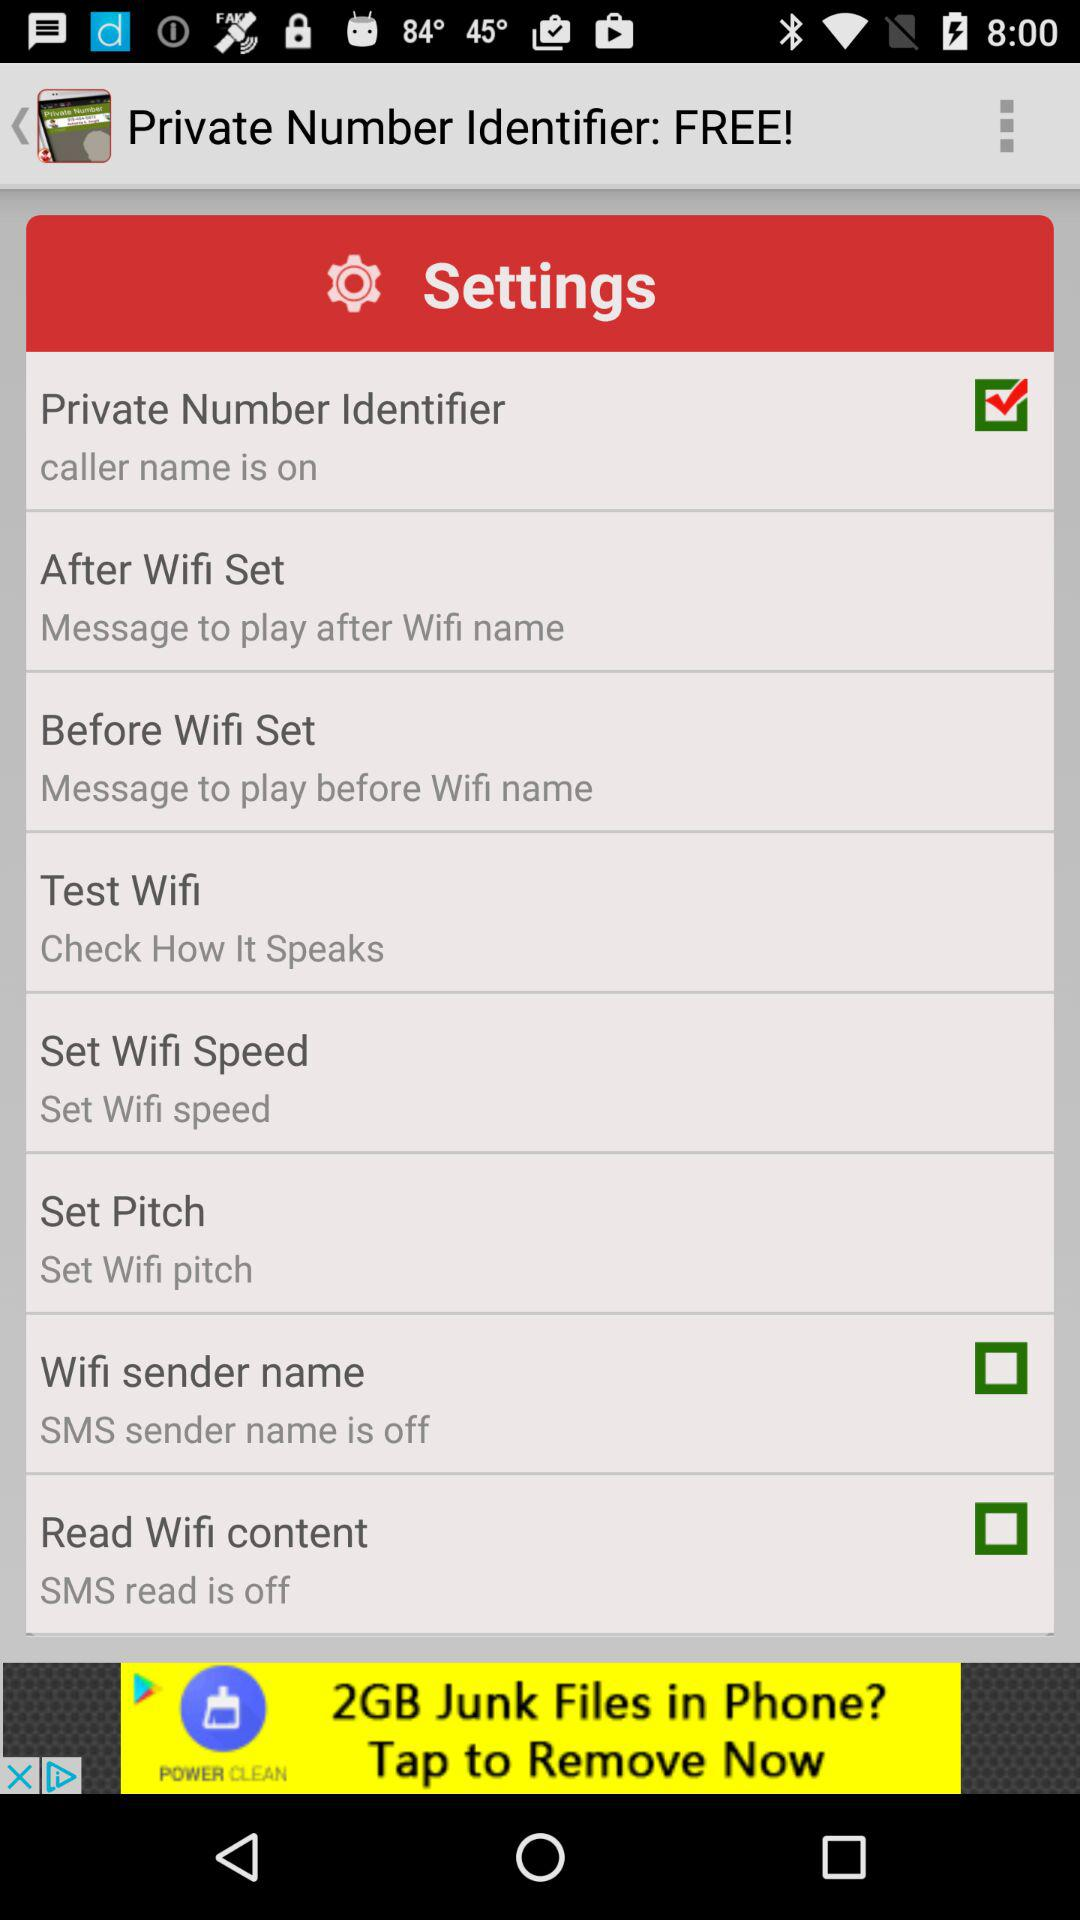What is the status of the "Wifi sender name"? The status is "off". 